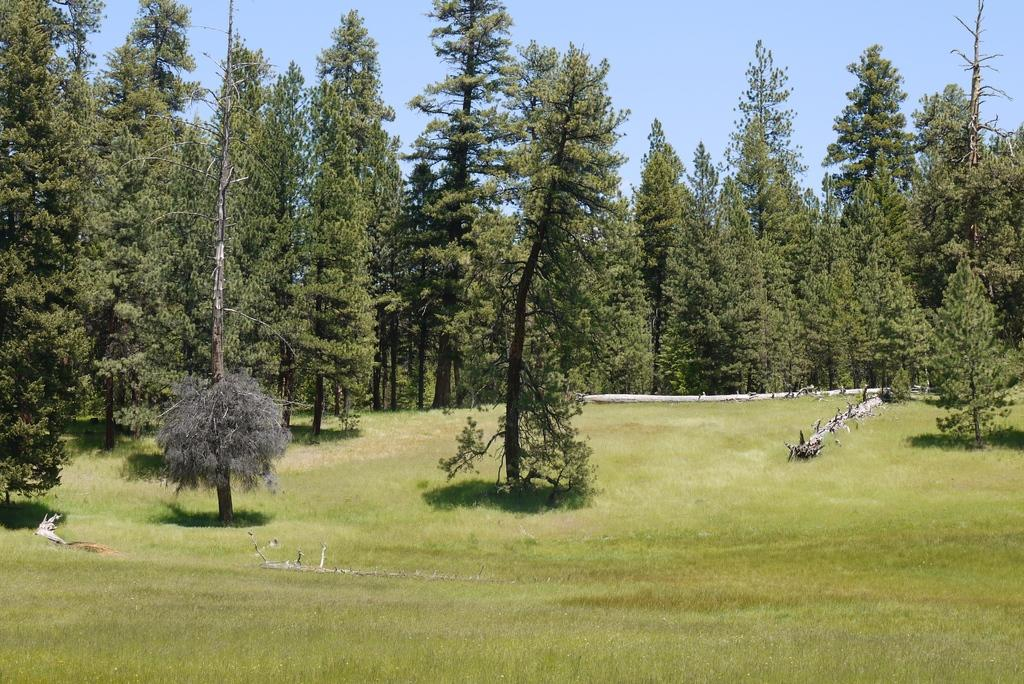What type of vegetation is present in the image? There are trees with branches and leaves in the image. What part of the tree is visible in the image? There is a tree trunk in the image. What type of ground cover is present in the image? There is grass in the image. What color is the grass in the image? The grass is green in color. What is visible at the top of the image? The sky is visible at the top of the image. How many bottles of ink can be seen on the tree branches in the image? There are no bottles of ink present on the tree branches in the image. Are there any visitors interacting with the trees in the image? There is no indication of any visitors interacting with the trees in the image. 